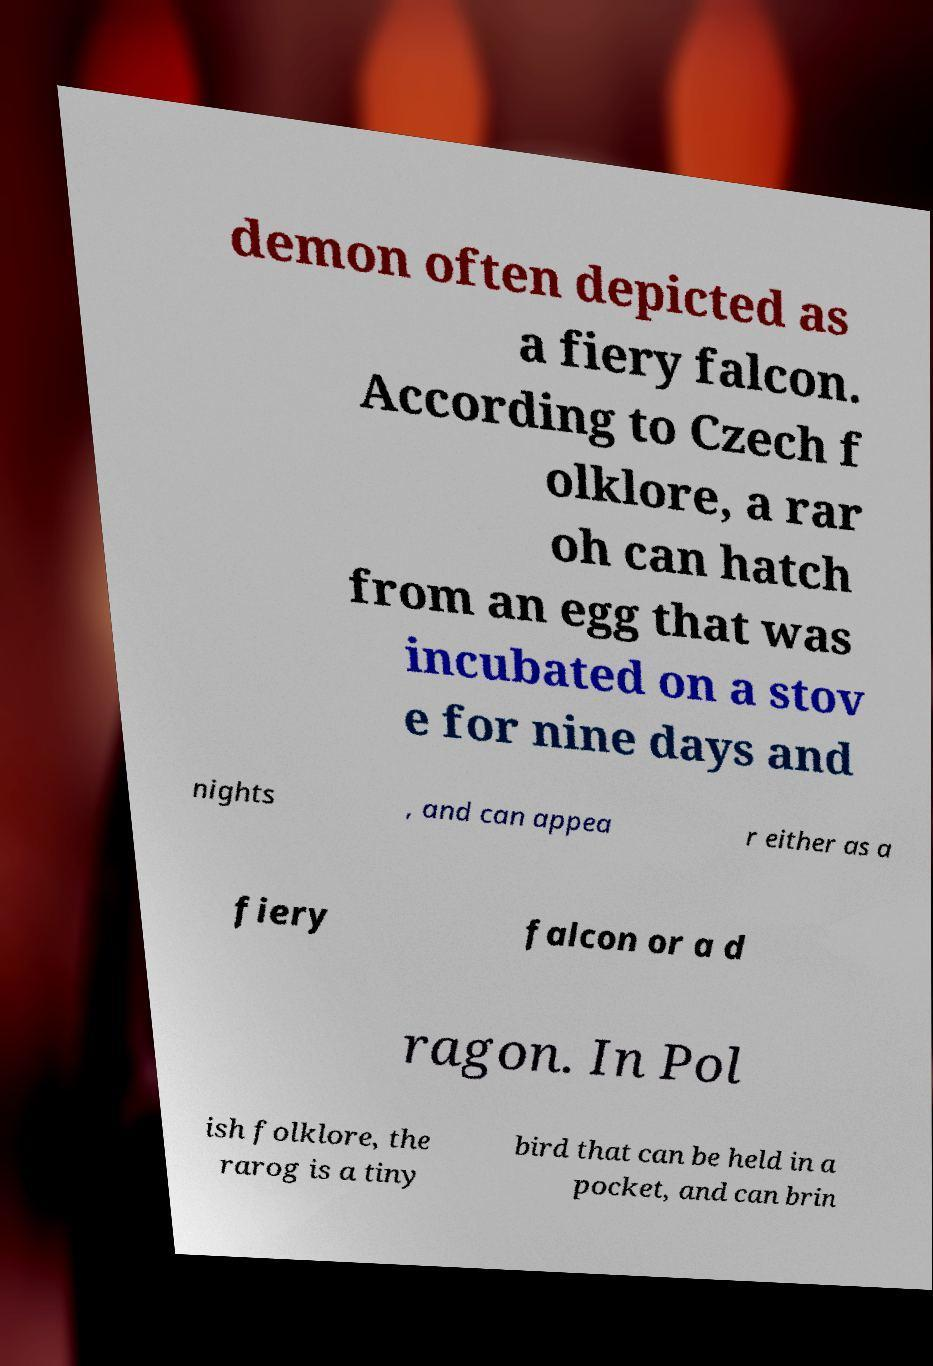Can you read and provide the text displayed in the image?This photo seems to have some interesting text. Can you extract and type it out for me? demon often depicted as a fiery falcon. According to Czech f olklore, a rar oh can hatch from an egg that was incubated on a stov e for nine days and nights , and can appea r either as a fiery falcon or a d ragon. In Pol ish folklore, the rarog is a tiny bird that can be held in a pocket, and can brin 